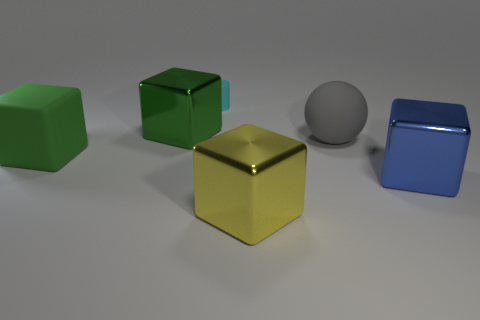How does the lighting affect the appearance of the different materials in the objects shown? The scene is lit in a way that accentuates the material properties of the objects. Metallic surfaces, like the cubes, reflect light sharply, highlighting their edges and faces. The matte sphere, on the other hand, shows a gentle gradient of shadow, displaying the subtlety of its surface. The interplay of light and shadow defines the visual volume of each object and brings out the uniqueness of their materials. 